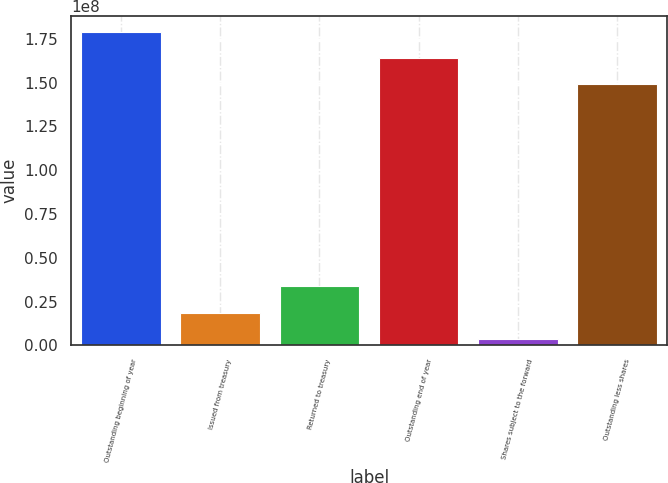<chart> <loc_0><loc_0><loc_500><loc_500><bar_chart><fcel>Outstanding beginning of year<fcel>Issued from treasury<fcel>Returned to treasury<fcel>Outstanding end of year<fcel>Shares subject to the forward<fcel>Outstanding less shares<nl><fcel>1.78974e+08<fcel>1.86754e+07<fcel>3.37053e+07<fcel>1.63944e+08<fcel>3.64551e+06<fcel>1.48914e+08<nl></chart> 